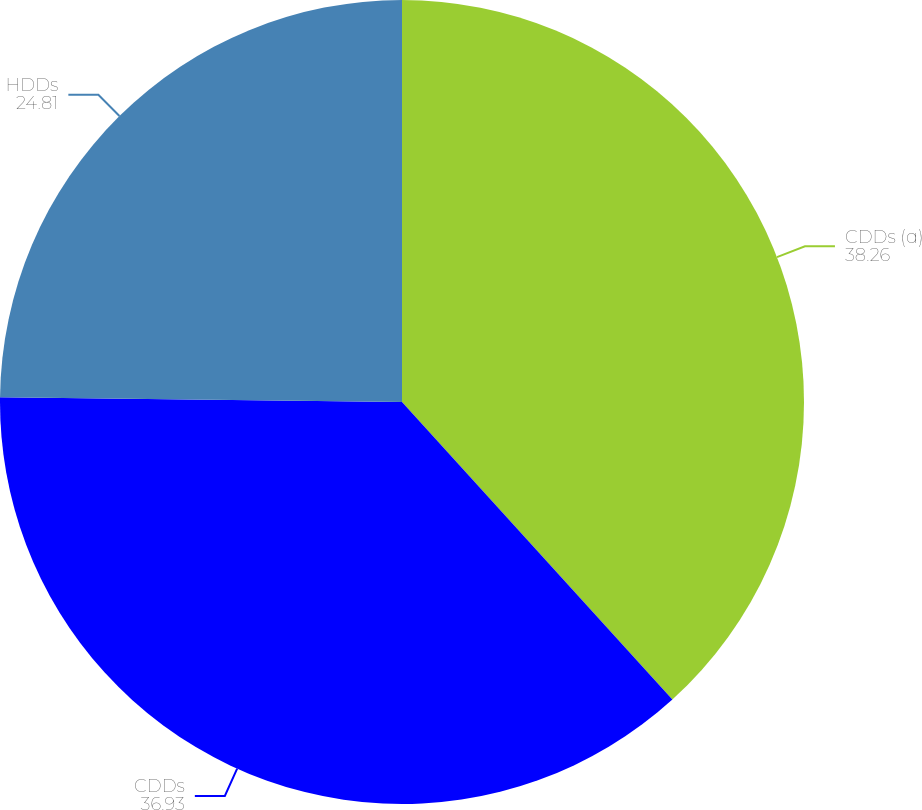<chart> <loc_0><loc_0><loc_500><loc_500><pie_chart><fcel>CDDs (a)<fcel>CDDs<fcel>HDDs<nl><fcel>38.26%<fcel>36.93%<fcel>24.81%<nl></chart> 